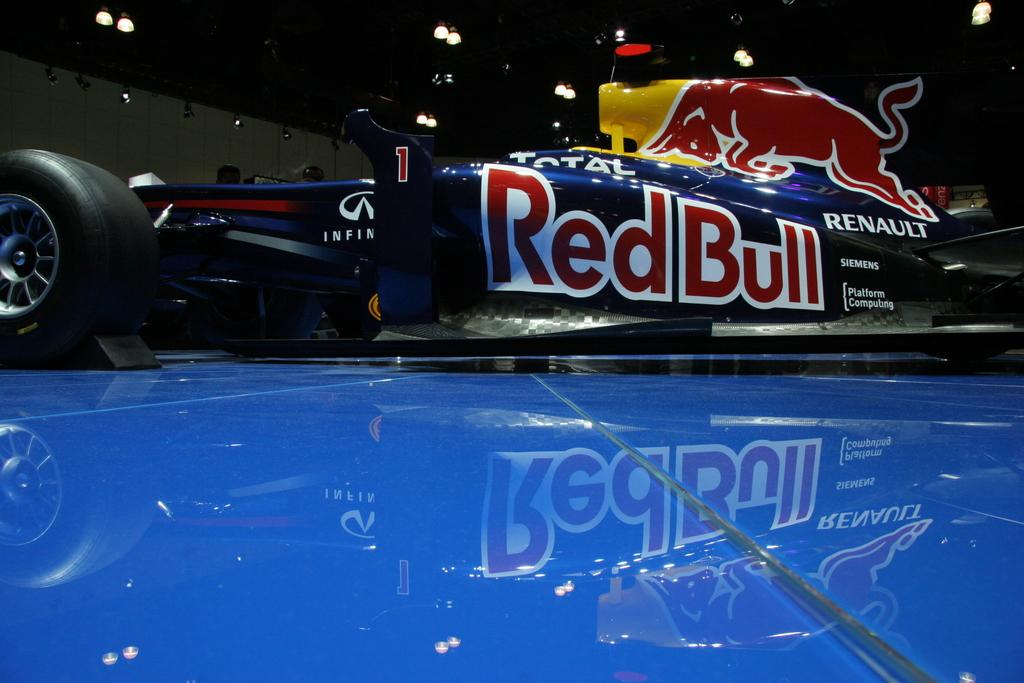What is the main subject of the image? There is a vehicle in the image. What is the color of the surface the vehicle is on? The vehicle is on a blue surface. What can be seen in the background of the image? There are lights and a wall in the background of the image. Can you tell me how many goldfish are swimming in the vehicle's engine in the image? There are no goldfish present in the image, and they would not be swimming in the vehicle's engine. 